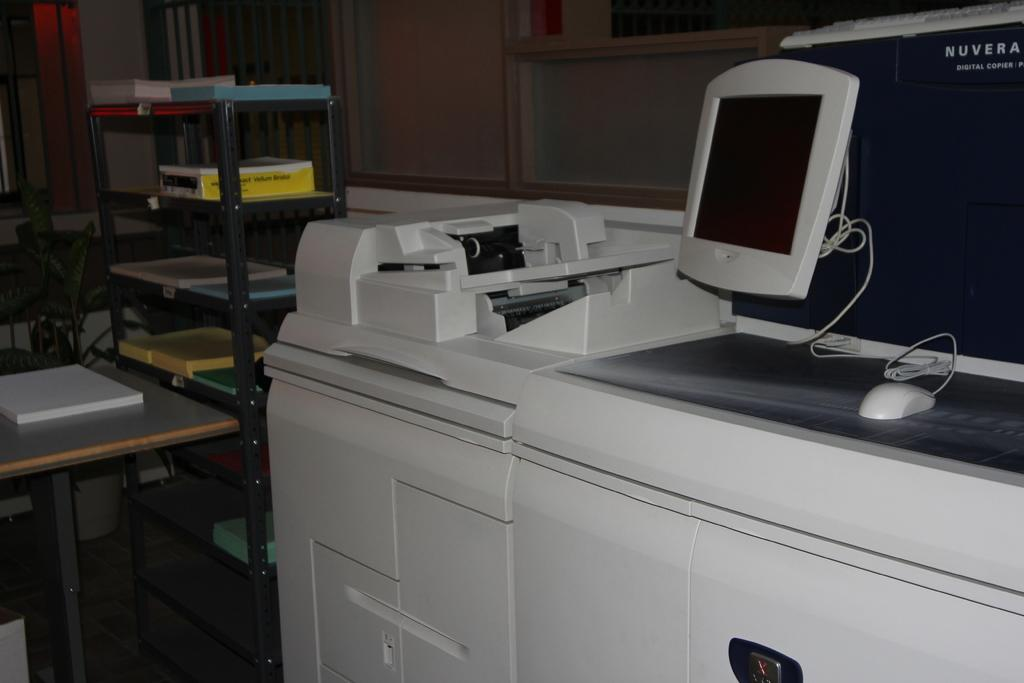<image>
Summarize the visual content of the image. A Nuvera copy machine has a mouse and a monitor on it. 